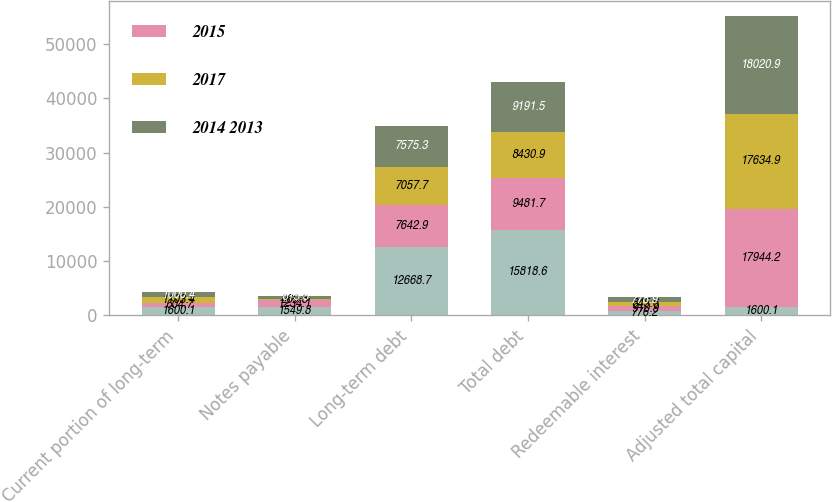<chart> <loc_0><loc_0><loc_500><loc_500><stacked_bar_chart><ecel><fcel>Current portion of long-term<fcel>Notes payable<fcel>Long-term debt<fcel>Total debt<fcel>Redeemable interest<fcel>Adjusted total capital<nl><fcel>nan<fcel>1600.1<fcel>1549.8<fcel>12668.7<fcel>15818.6<fcel>776.2<fcel>1600.1<nl><fcel>2015<fcel>604.7<fcel>1234.1<fcel>7642.9<fcel>9481.7<fcel>910.9<fcel>17944.2<nl><fcel>2017<fcel>1103.4<fcel>269.8<fcel>7057.7<fcel>8430.9<fcel>845.6<fcel>17634.9<nl><fcel>2014 2013<fcel>1000.4<fcel>615.8<fcel>7575.3<fcel>9191.5<fcel>778.9<fcel>18020.9<nl></chart> 